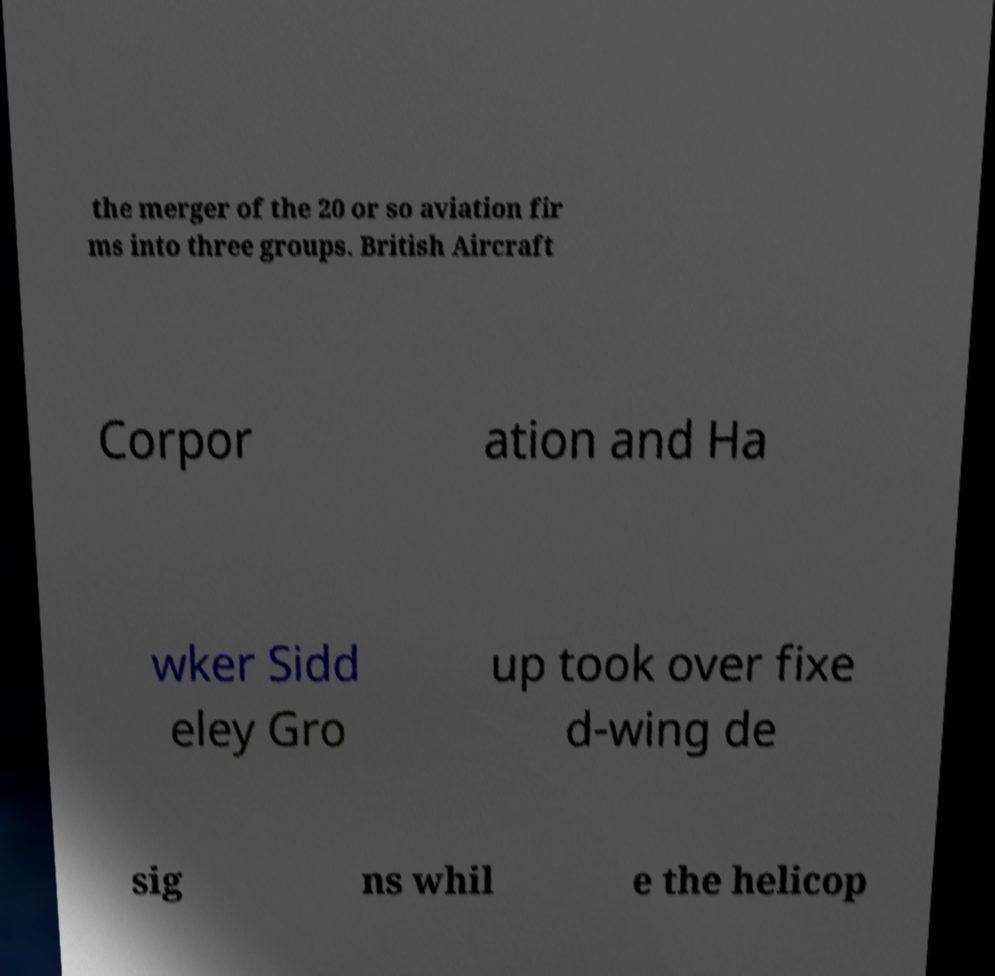There's text embedded in this image that I need extracted. Can you transcribe it verbatim? the merger of the 20 or so aviation fir ms into three groups. British Aircraft Corpor ation and Ha wker Sidd eley Gro up took over fixe d-wing de sig ns whil e the helicop 